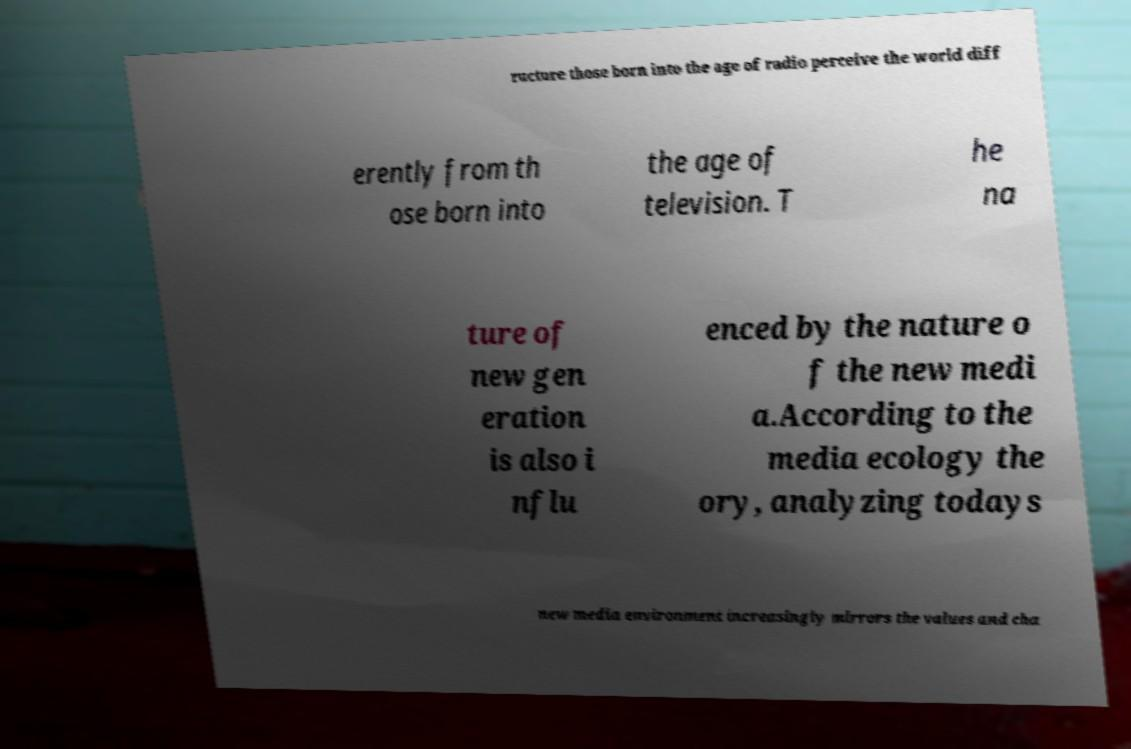Can you read and provide the text displayed in the image?This photo seems to have some interesting text. Can you extract and type it out for me? ructure those born into the age of radio perceive the world diff erently from th ose born into the age of television. T he na ture of new gen eration is also i nflu enced by the nature o f the new medi a.According to the media ecology the ory, analyzing todays new media environment increasingly mirrors the values and cha 